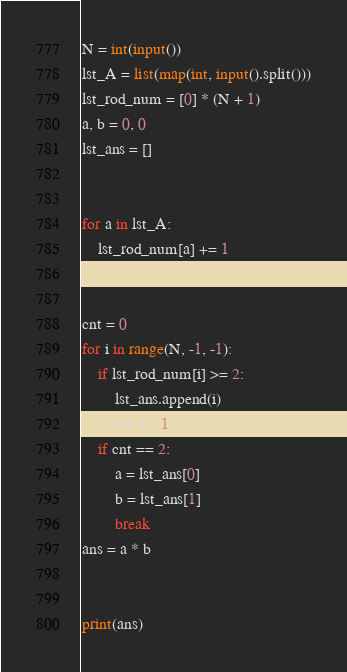<code> <loc_0><loc_0><loc_500><loc_500><_Python_>N = int(input())
lst_A = list(map(int, input().split()))
lst_rod_num = [0] * (N + 1)
a, b = 0, 0
lst_ans = []


for a in lst_A:
    lst_rod_num[a] += 1


cnt = 0
for i in range(N, -1, -1):
    if lst_rod_num[i] >= 2:
        lst_ans.append(i)
        cnt += 1
    if cnt == 2:
        a = lst_ans[0]
        b = lst_ans[1]
        break
ans = a * b


print(ans)</code> 